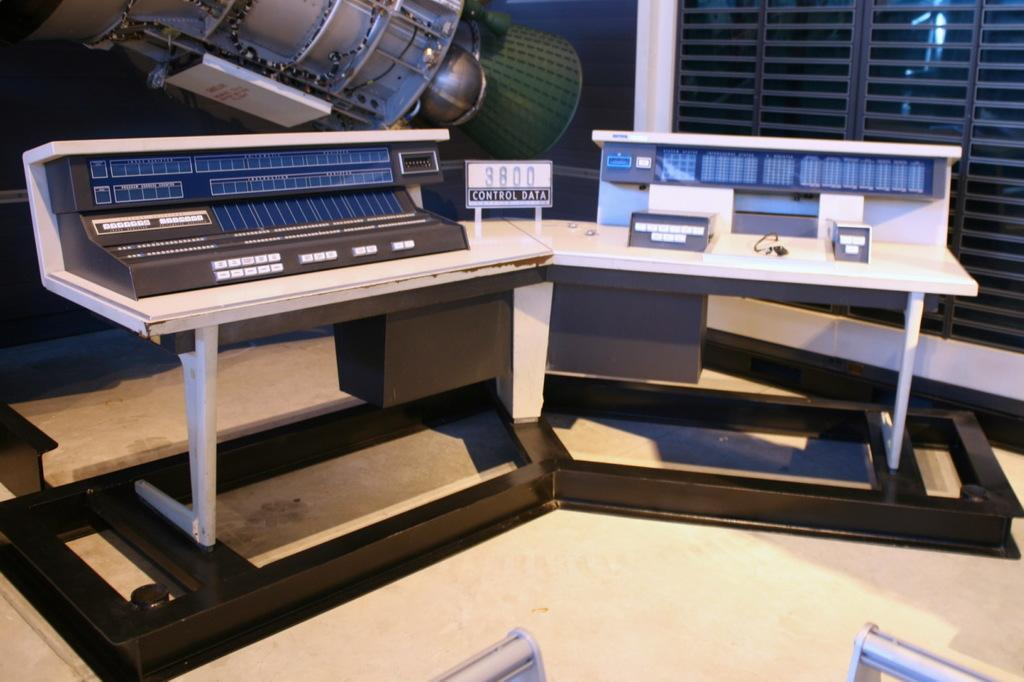What is the main object in the image? There is a board in the image. What else can be seen in the image besides the board? There are objects on tables in the image. What can be seen in the background of the image? There is a machine and a window in the background of the image. What type of bells can be heard ringing in the image? There are no bells present in the image, and therefore no sound can be heard. 